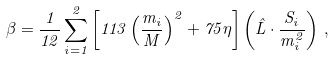<formula> <loc_0><loc_0><loc_500><loc_500>\beta = \frac { 1 } { 1 2 } \sum _ { i = 1 } ^ { 2 } \left [ 1 1 3 \left ( \frac { m _ { i } } { M } \right ) ^ { 2 } + 7 5 \eta \right ] \left ( \hat { L } \cdot \frac { S _ { i } } { m _ { i } ^ { 2 } } \right ) \, ,</formula> 